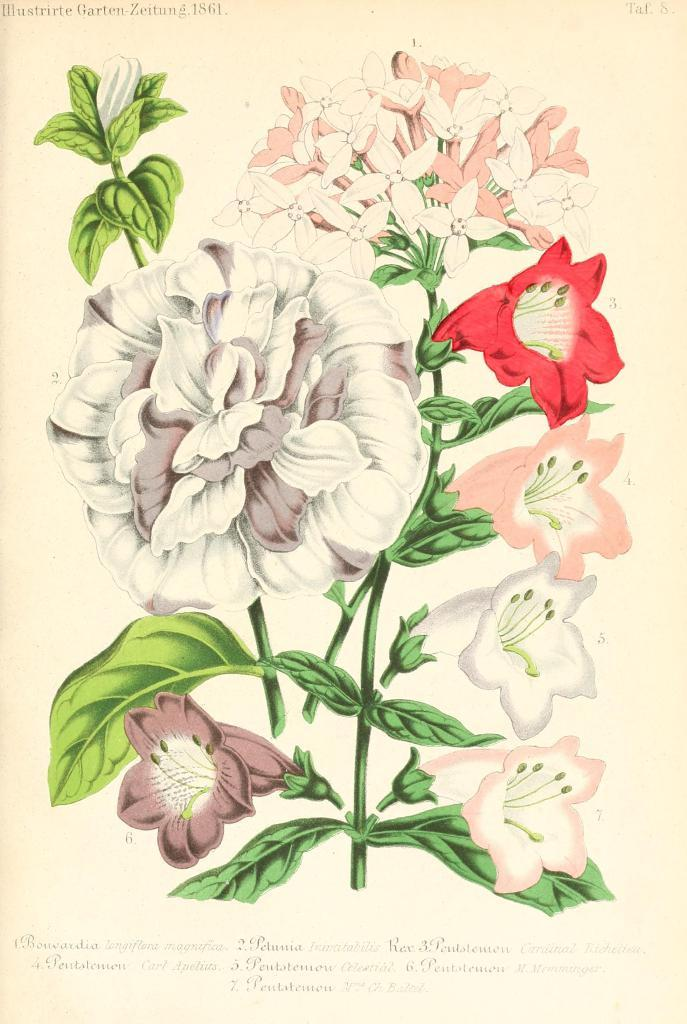What is the main subject of the image? The main subject of the image is an art piece on a paper. Can you describe the art piece in the image? Unfortunately, the image does not provide enough detail to describe the art piece. What type of material is the art piece created on? The art piece is created on a paper, as mentioned in the fact. How many tubes of glue are used in the art piece? There is no information about glue or the materials used in the art piece in the provided fact. Therefore, we cannot determine how many tubes of glue were used. What type of note is attached to the art piece? There is no mention of a note attached to the art piece in the provided fact. 